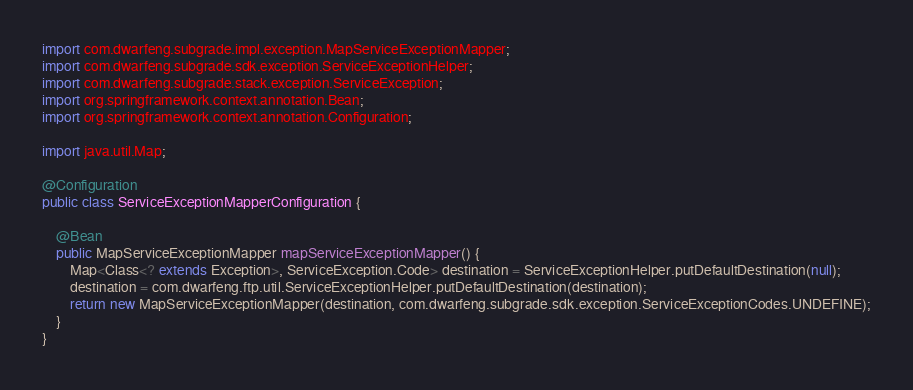Convert code to text. <code><loc_0><loc_0><loc_500><loc_500><_Java_>import com.dwarfeng.subgrade.impl.exception.MapServiceExceptionMapper;
import com.dwarfeng.subgrade.sdk.exception.ServiceExceptionHelper;
import com.dwarfeng.subgrade.stack.exception.ServiceException;
import org.springframework.context.annotation.Bean;
import org.springframework.context.annotation.Configuration;

import java.util.Map;

@Configuration
public class ServiceExceptionMapperConfiguration {

    @Bean
    public MapServiceExceptionMapper mapServiceExceptionMapper() {
        Map<Class<? extends Exception>, ServiceException.Code> destination = ServiceExceptionHelper.putDefaultDestination(null);
        destination = com.dwarfeng.ftp.util.ServiceExceptionHelper.putDefaultDestination(destination);
        return new MapServiceExceptionMapper(destination, com.dwarfeng.subgrade.sdk.exception.ServiceExceptionCodes.UNDEFINE);
    }
}
</code> 